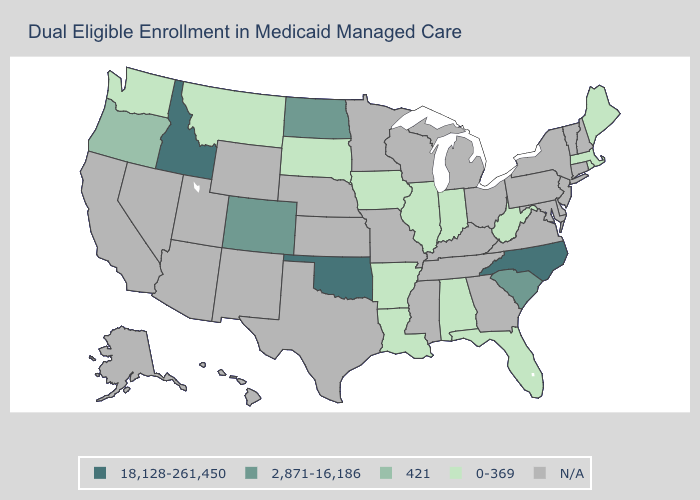Name the states that have a value in the range 2,871-16,186?
Keep it brief. Colorado, North Dakota, South Carolina. Which states have the lowest value in the USA?
Keep it brief. Alabama, Arkansas, Florida, Illinois, Indiana, Iowa, Louisiana, Maine, Massachusetts, Montana, Rhode Island, South Dakota, Washington, West Virginia. Among the states that border Texas , which have the lowest value?
Be succinct. Arkansas, Louisiana. What is the lowest value in states that border Virginia?
Give a very brief answer. 0-369. What is the lowest value in states that border Wyoming?
Quick response, please. 0-369. Name the states that have a value in the range 0-369?
Answer briefly. Alabama, Arkansas, Florida, Illinois, Indiana, Iowa, Louisiana, Maine, Massachusetts, Montana, Rhode Island, South Dakota, Washington, West Virginia. Name the states that have a value in the range 421?
Quick response, please. Oregon. What is the value of Tennessee?
Answer briefly. N/A. Name the states that have a value in the range 2,871-16,186?
Answer briefly. Colorado, North Dakota, South Carolina. What is the value of Colorado?
Keep it brief. 2,871-16,186. What is the highest value in states that border Illinois?
Keep it brief. 0-369. What is the highest value in states that border Kansas?
Answer briefly. 18,128-261,450. Name the states that have a value in the range 2,871-16,186?
Give a very brief answer. Colorado, North Dakota, South Carolina. Name the states that have a value in the range 0-369?
Short answer required. Alabama, Arkansas, Florida, Illinois, Indiana, Iowa, Louisiana, Maine, Massachusetts, Montana, Rhode Island, South Dakota, Washington, West Virginia. 